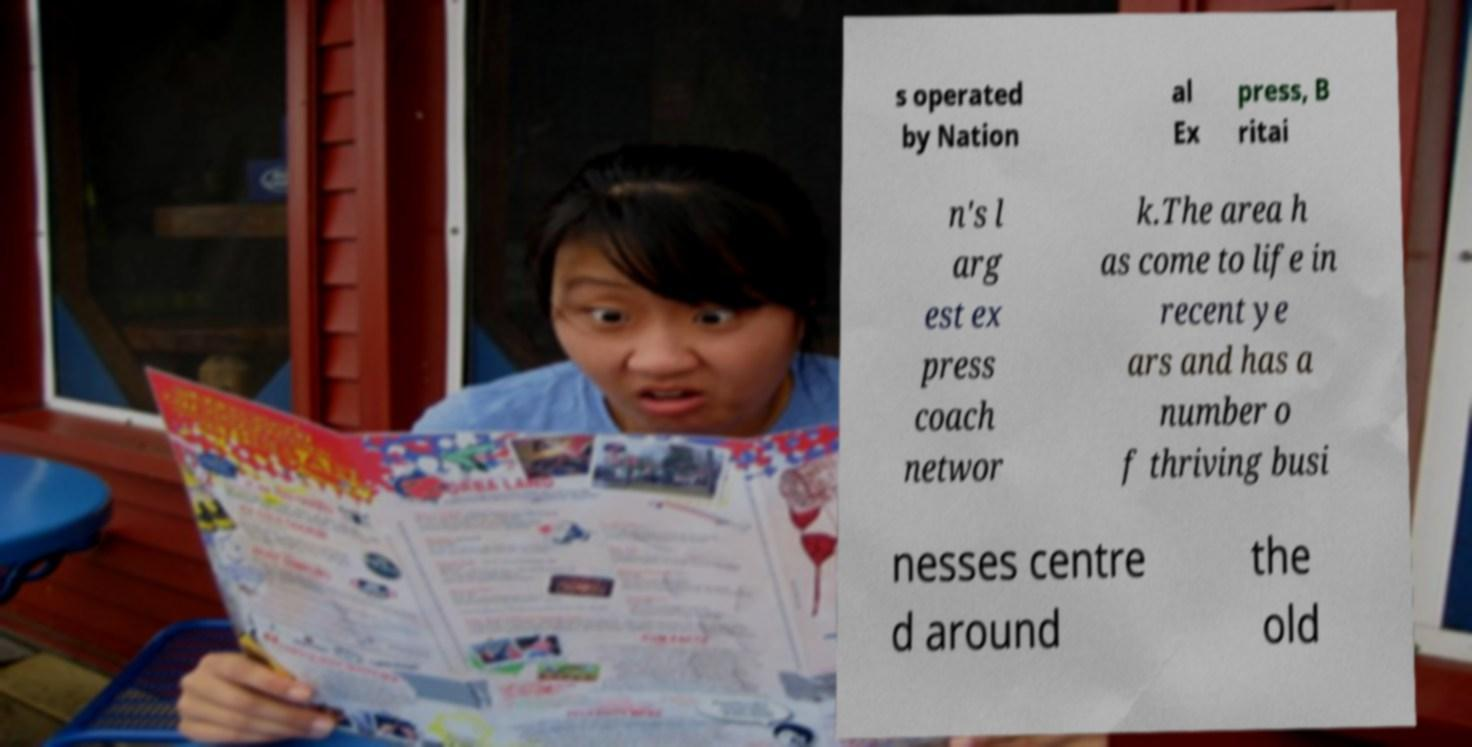Please read and relay the text visible in this image. What does it say? s operated by Nation al Ex press, B ritai n's l arg est ex press coach networ k.The area h as come to life in recent ye ars and has a number o f thriving busi nesses centre d around the old 